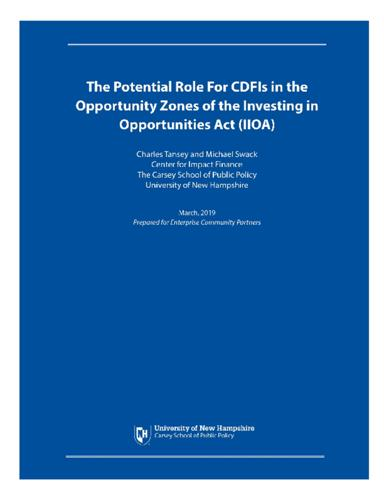When was the document published? This insightful document was published in March 2019, as indicated by the date mentioned on its cover. 